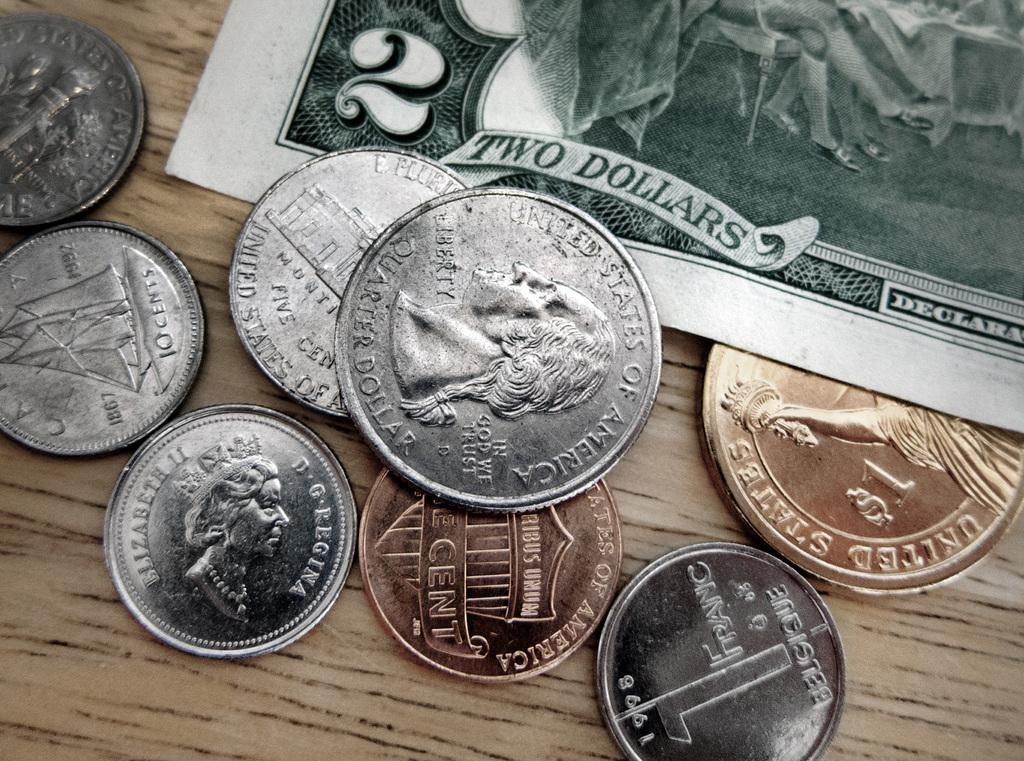Provide a one-sentence caption for the provided image. The two dollar bill is green and crisp in lettering amongst the In God We Trust slogan on the quarter. 